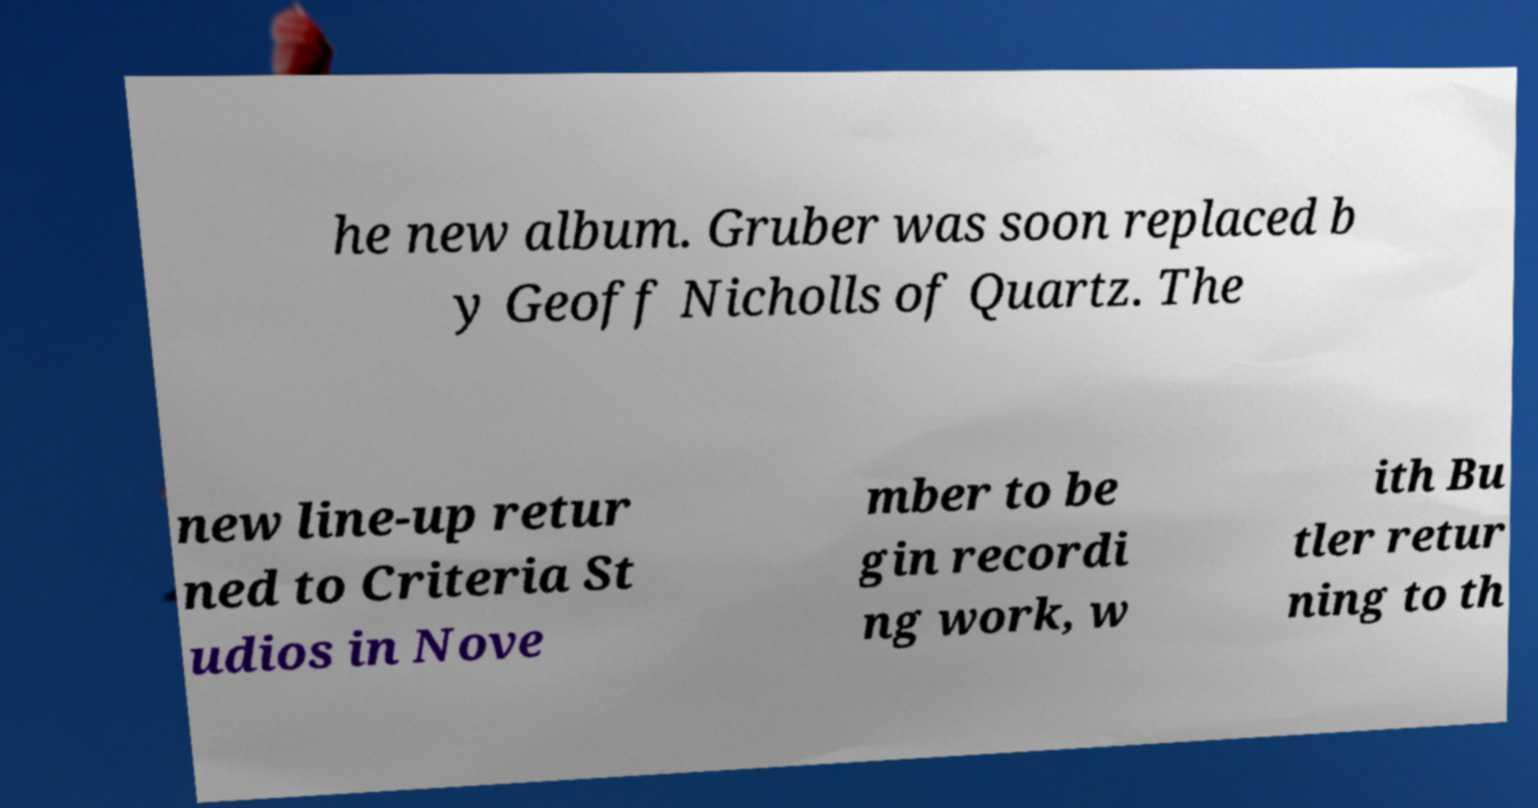Can you read and provide the text displayed in the image?This photo seems to have some interesting text. Can you extract and type it out for me? he new album. Gruber was soon replaced b y Geoff Nicholls of Quartz. The new line-up retur ned to Criteria St udios in Nove mber to be gin recordi ng work, w ith Bu tler retur ning to th 